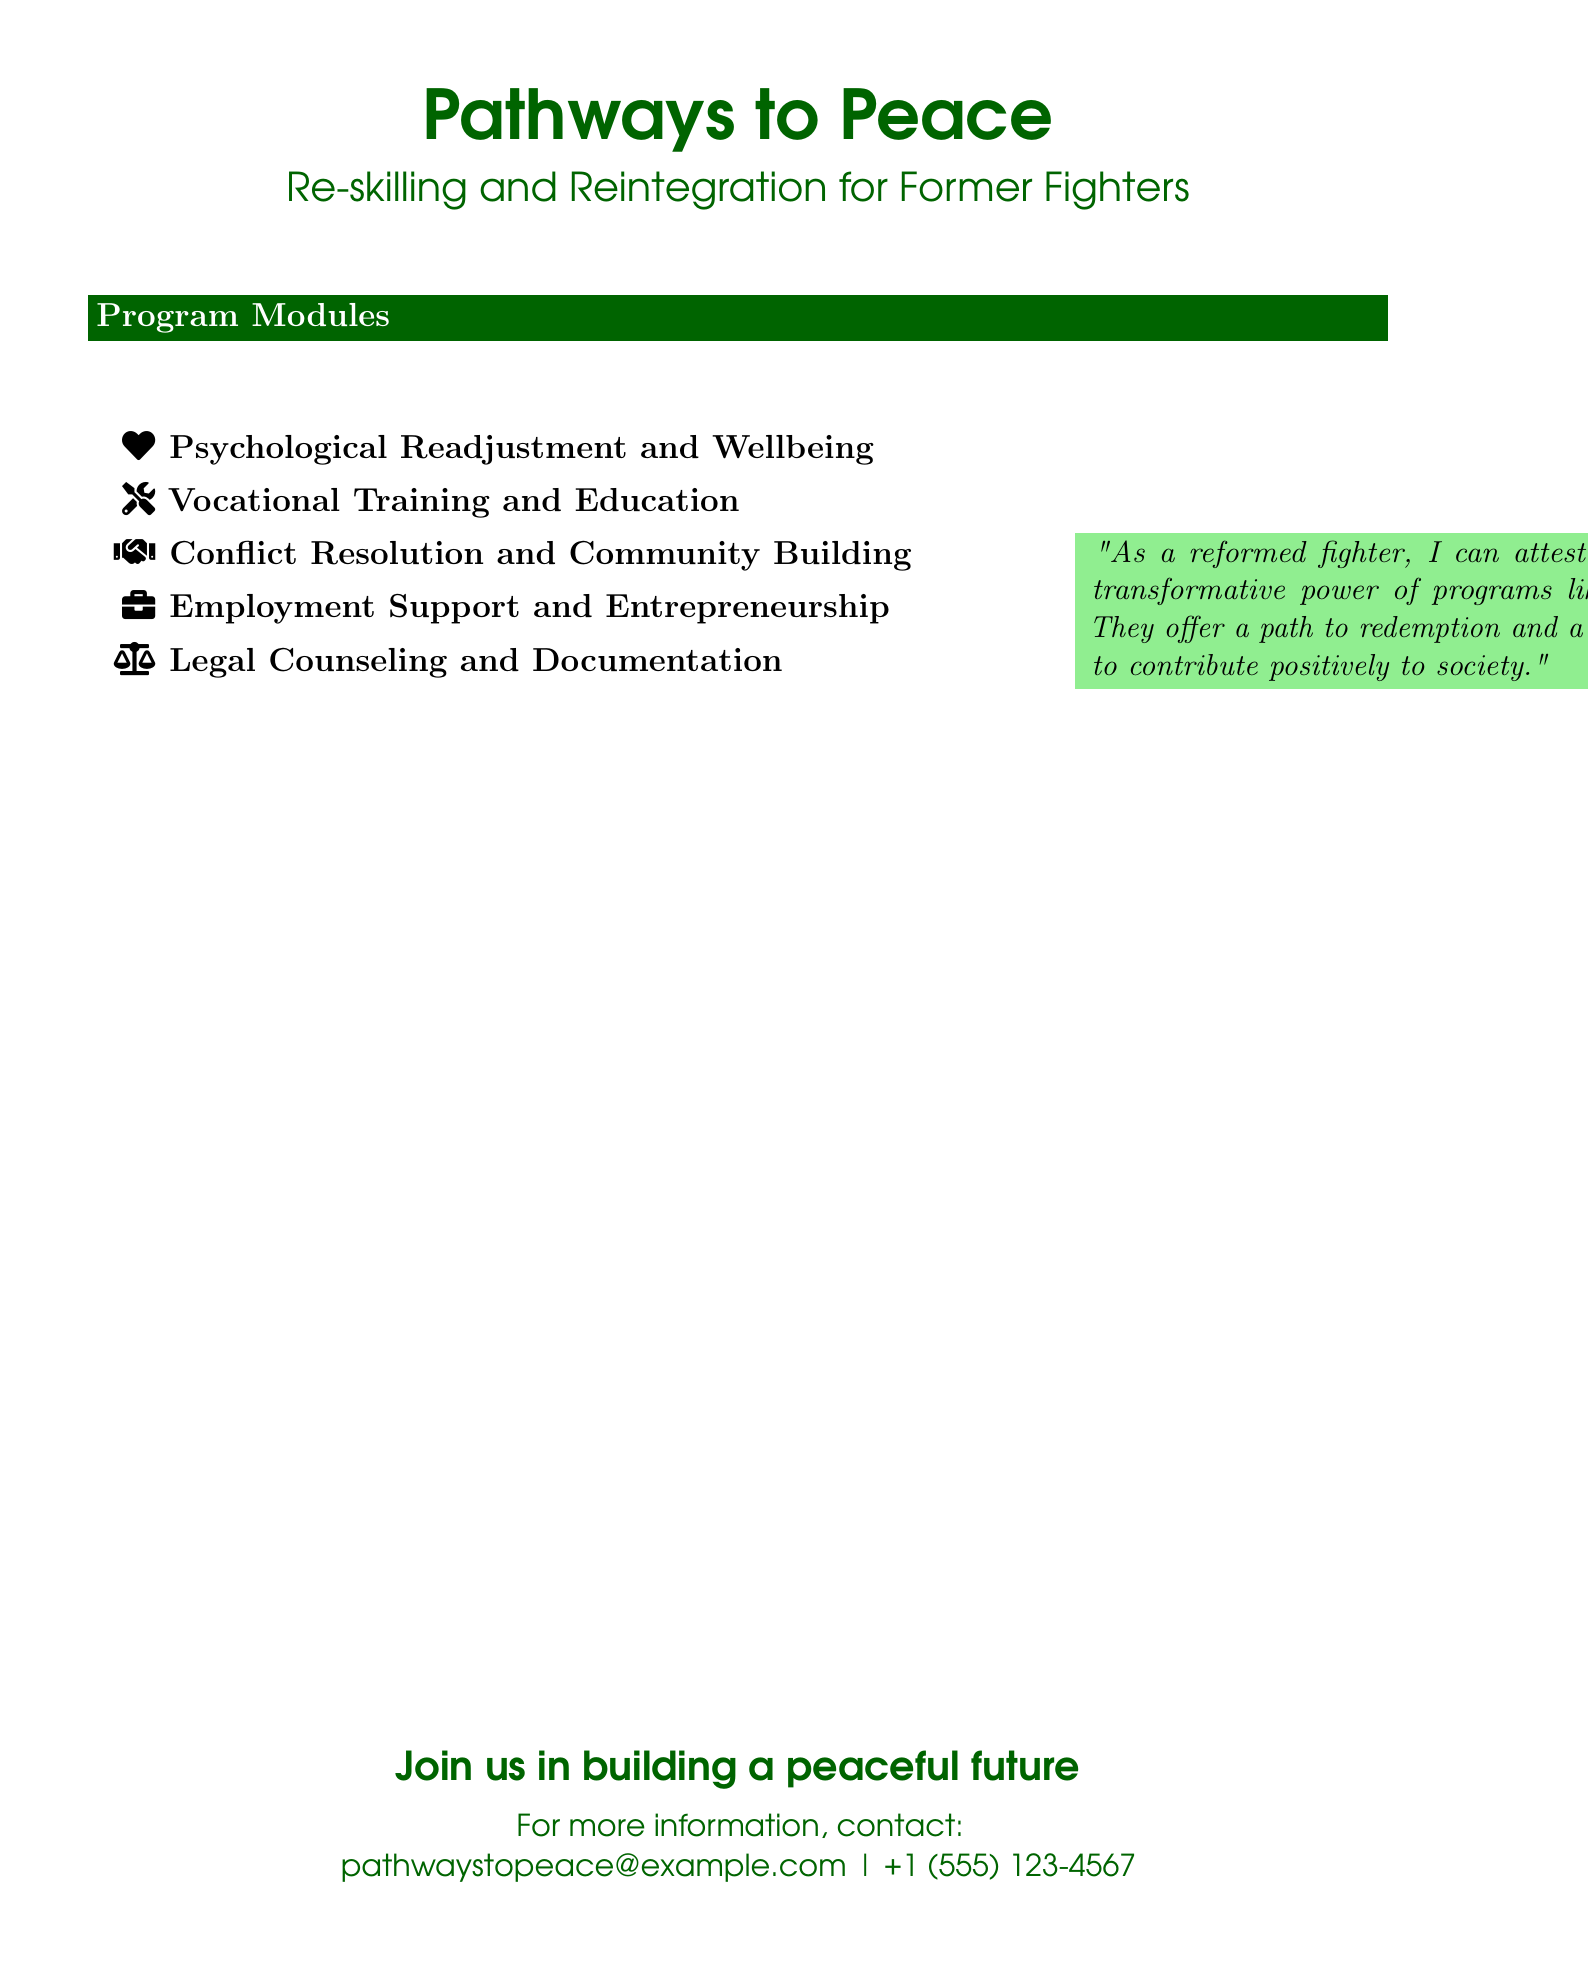What is the title of the program? The title of the program, as indicated in the document, is "Pathways to Peace."
Answer: Pathways to Peace How many program modules are listed? The document lists five specific program modules aimed at re-skilling and reintegration.
Answer: 5 What is the focus of the first module? The first module focuses on psychological aspects that are crucial for readjustment and wellbeing.
Answer: Psychological Readjustment and Wellbeing Which module addresses community engagement? The module that addresses community engagement is focused on resolving conflicts and building communities.
Answer: Conflict Resolution and Community Building What contact method is provided for more information? The document provides an email address as a contact method for additional information regarding the program.
Answer: pathwaystopeace@example.com What color highlights the program title? The program title uses a dark green color for highlighting.
Answer: Dark green Which element is included to give credibility to the program? A quotation from a reformed fighter is included to endorse the program's effectiveness and transformative power.
Answer: Quotation What type of support does the fourth module offer? The fourth module offers guidance and assistance for employment and entrepreneurship opportunities.
Answer: Employment Support and Entrepreneurship What is the primary objective of the legal counseling module? The legal counseling module aims to provide information and support regarding legal documentation and issues.
Answer: Legal Counseling and Documentation 